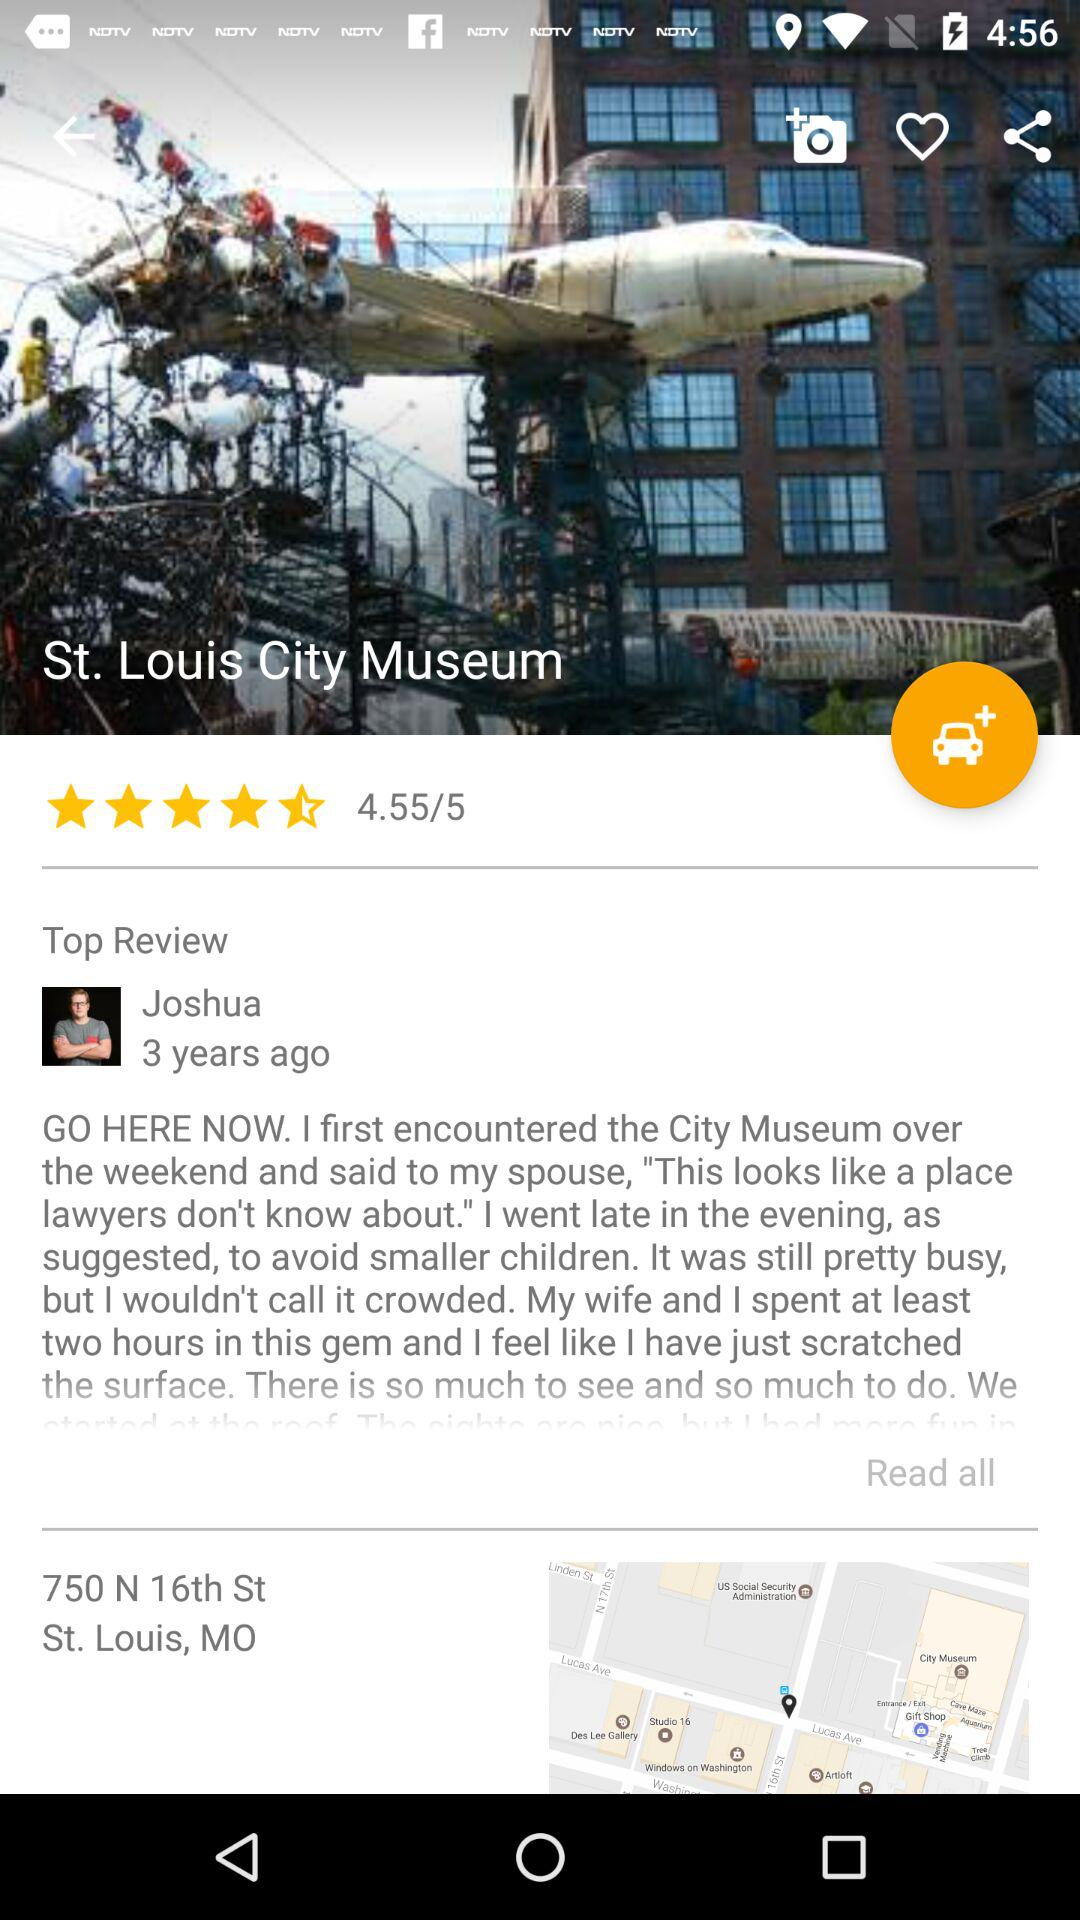Who posted the review? The review was posted by Joshua. 